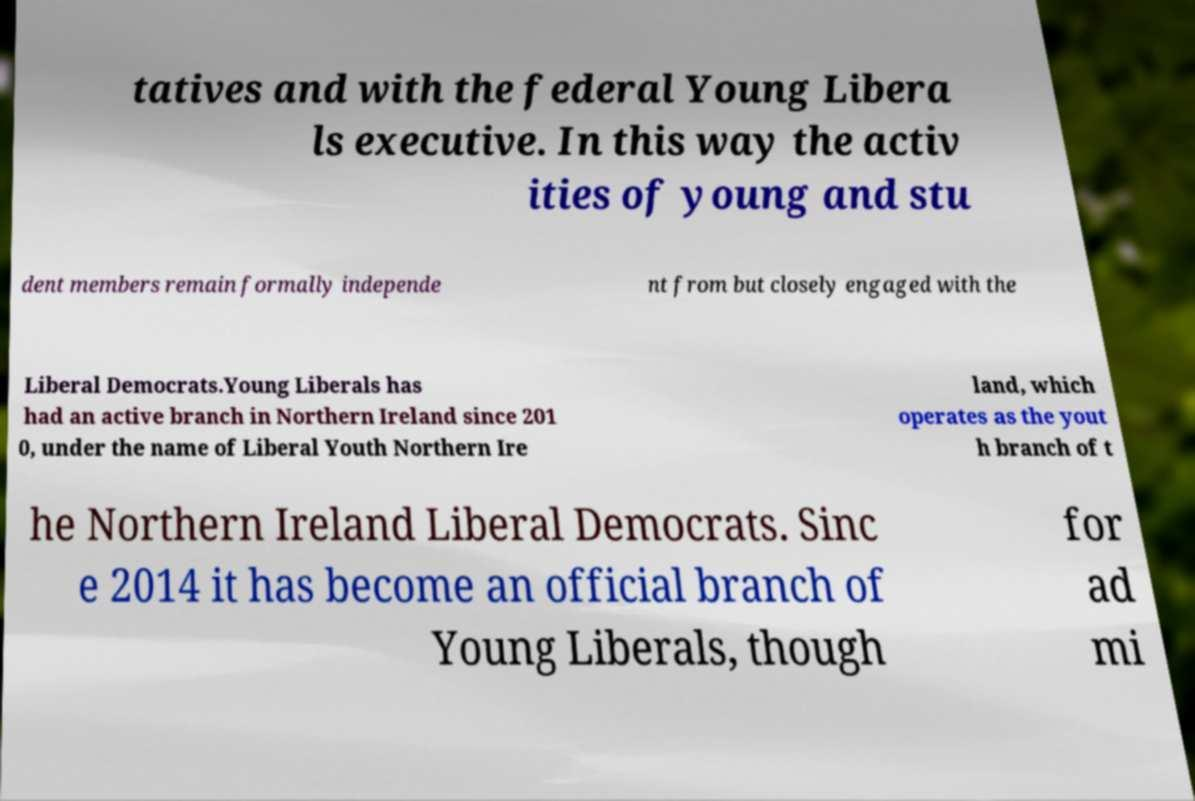Please read and relay the text visible in this image. What does it say? tatives and with the federal Young Libera ls executive. In this way the activ ities of young and stu dent members remain formally independe nt from but closely engaged with the Liberal Democrats.Young Liberals has had an active branch in Northern Ireland since 201 0, under the name of Liberal Youth Northern Ire land, which operates as the yout h branch of t he Northern Ireland Liberal Democrats. Sinc e 2014 it has become an official branch of Young Liberals, though for ad mi 